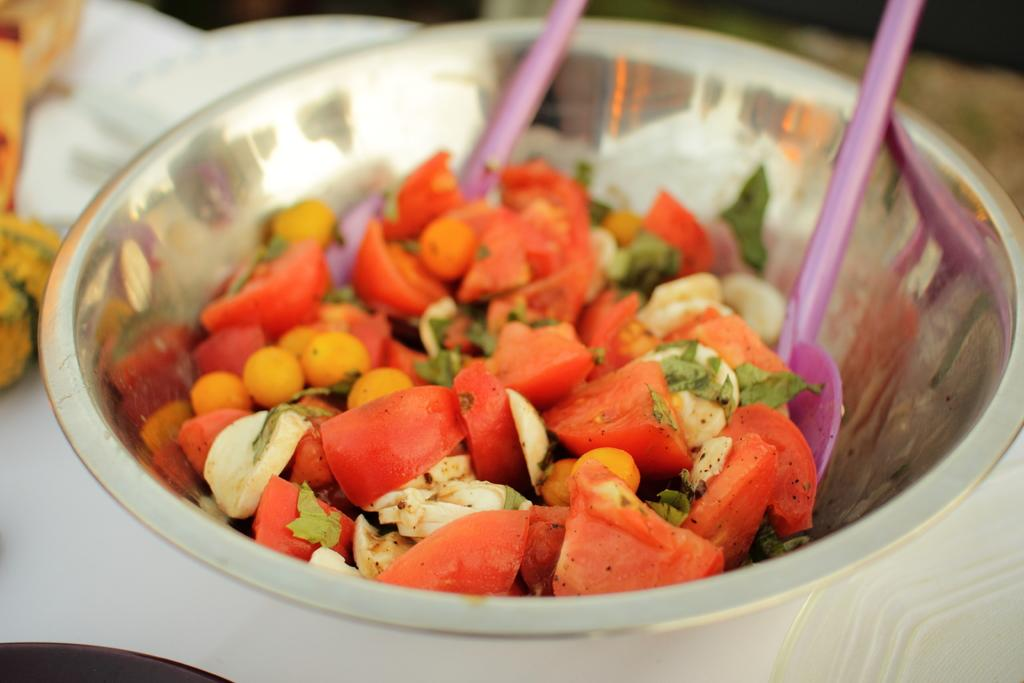What is present in the image that people might eat? There is food in the image. What utensils are used with the food in the image? There are spoons in the bowl. Where is the bowl with the food and spoons located? The bowl is placed on a table. How many cattle can be seen grazing in the image? There are no cattle present in the image. Is there a horse visible in the image? There is no horse present in the image. 